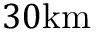Convert formula to latex. <formula><loc_0><loc_0><loc_500><loc_500>3 0 k m</formula> 